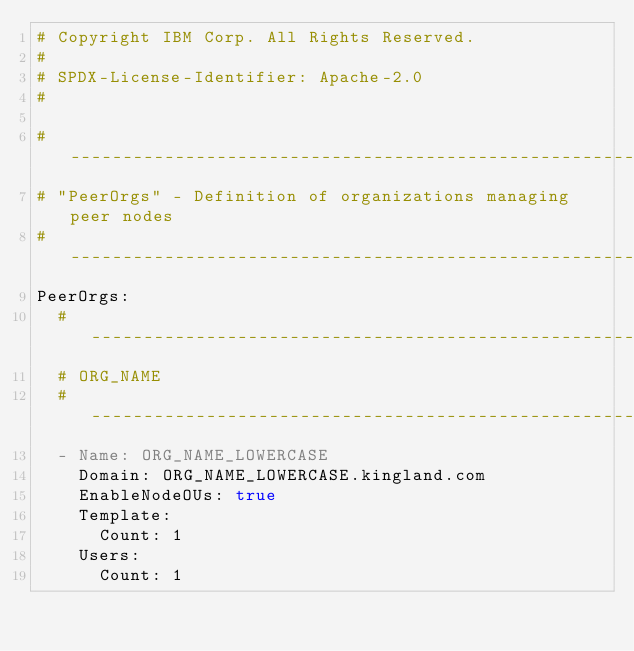Convert code to text. <code><loc_0><loc_0><loc_500><loc_500><_YAML_># Copyright IBM Corp. All Rights Reserved.
#
# SPDX-License-Identifier: Apache-2.0
#

# ---------------------------------------------------------------------------
# "PeerOrgs" - Definition of organizations managing peer nodes
# ---------------------------------------------------------------------------
PeerOrgs:
  # ---------------------------------------------------------------------------
  # ORG_NAME
  # ---------------------------------------------------------------------------
  - Name: ORG_NAME_LOWERCASE
    Domain: ORG_NAME_LOWERCASE.kingland.com
    EnableNodeOUs: true
    Template:
      Count: 1
    Users:
      Count: 1
</code> 